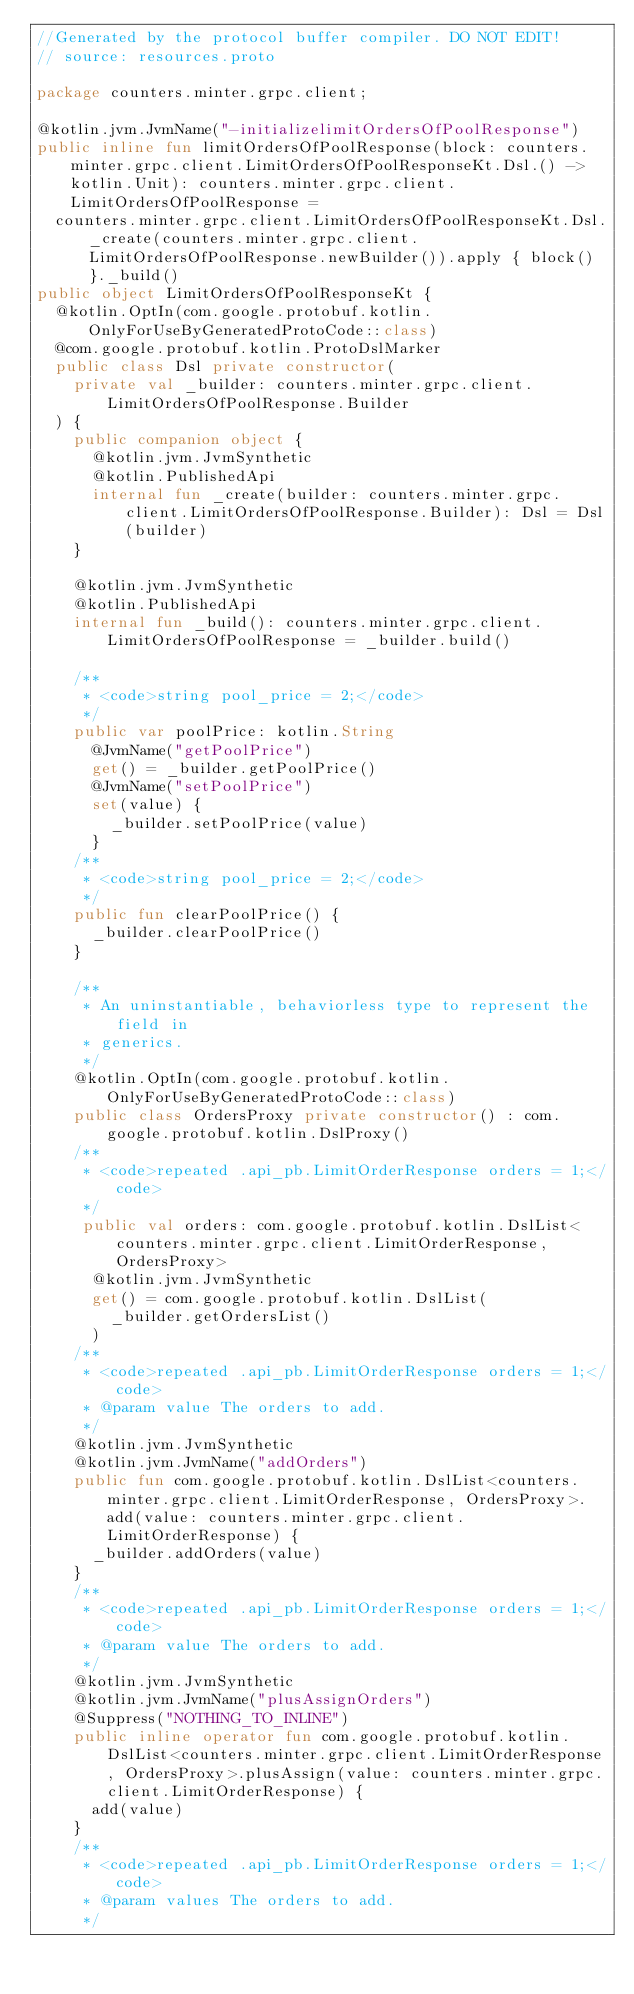<code> <loc_0><loc_0><loc_500><loc_500><_Kotlin_>//Generated by the protocol buffer compiler. DO NOT EDIT!
// source: resources.proto

package counters.minter.grpc.client;

@kotlin.jvm.JvmName("-initializelimitOrdersOfPoolResponse")
public inline fun limitOrdersOfPoolResponse(block: counters.minter.grpc.client.LimitOrdersOfPoolResponseKt.Dsl.() -> kotlin.Unit): counters.minter.grpc.client.LimitOrdersOfPoolResponse =
  counters.minter.grpc.client.LimitOrdersOfPoolResponseKt.Dsl._create(counters.minter.grpc.client.LimitOrdersOfPoolResponse.newBuilder()).apply { block() }._build()
public object LimitOrdersOfPoolResponseKt {
  @kotlin.OptIn(com.google.protobuf.kotlin.OnlyForUseByGeneratedProtoCode::class)
  @com.google.protobuf.kotlin.ProtoDslMarker
  public class Dsl private constructor(
    private val _builder: counters.minter.grpc.client.LimitOrdersOfPoolResponse.Builder
  ) {
    public companion object {
      @kotlin.jvm.JvmSynthetic
      @kotlin.PublishedApi
      internal fun _create(builder: counters.minter.grpc.client.LimitOrdersOfPoolResponse.Builder): Dsl = Dsl(builder)
    }

    @kotlin.jvm.JvmSynthetic
    @kotlin.PublishedApi
    internal fun _build(): counters.minter.grpc.client.LimitOrdersOfPoolResponse = _builder.build()

    /**
     * <code>string pool_price = 2;</code>
     */
    public var poolPrice: kotlin.String
      @JvmName("getPoolPrice")
      get() = _builder.getPoolPrice()
      @JvmName("setPoolPrice")
      set(value) {
        _builder.setPoolPrice(value)
      }
    /**
     * <code>string pool_price = 2;</code>
     */
    public fun clearPoolPrice() {
      _builder.clearPoolPrice()
    }

    /**
     * An uninstantiable, behaviorless type to represent the field in
     * generics.
     */
    @kotlin.OptIn(com.google.protobuf.kotlin.OnlyForUseByGeneratedProtoCode::class)
    public class OrdersProxy private constructor() : com.google.protobuf.kotlin.DslProxy()
    /**
     * <code>repeated .api_pb.LimitOrderResponse orders = 1;</code>
     */
     public val orders: com.google.protobuf.kotlin.DslList<counters.minter.grpc.client.LimitOrderResponse, OrdersProxy>
      @kotlin.jvm.JvmSynthetic
      get() = com.google.protobuf.kotlin.DslList(
        _builder.getOrdersList()
      )
    /**
     * <code>repeated .api_pb.LimitOrderResponse orders = 1;</code>
     * @param value The orders to add.
     */
    @kotlin.jvm.JvmSynthetic
    @kotlin.jvm.JvmName("addOrders")
    public fun com.google.protobuf.kotlin.DslList<counters.minter.grpc.client.LimitOrderResponse, OrdersProxy>.add(value: counters.minter.grpc.client.LimitOrderResponse) {
      _builder.addOrders(value)
    }
    /**
     * <code>repeated .api_pb.LimitOrderResponse orders = 1;</code>
     * @param value The orders to add.
     */
    @kotlin.jvm.JvmSynthetic
    @kotlin.jvm.JvmName("plusAssignOrders")
    @Suppress("NOTHING_TO_INLINE")
    public inline operator fun com.google.protobuf.kotlin.DslList<counters.minter.grpc.client.LimitOrderResponse, OrdersProxy>.plusAssign(value: counters.minter.grpc.client.LimitOrderResponse) {
      add(value)
    }
    /**
     * <code>repeated .api_pb.LimitOrderResponse orders = 1;</code>
     * @param values The orders to add.
     */</code> 